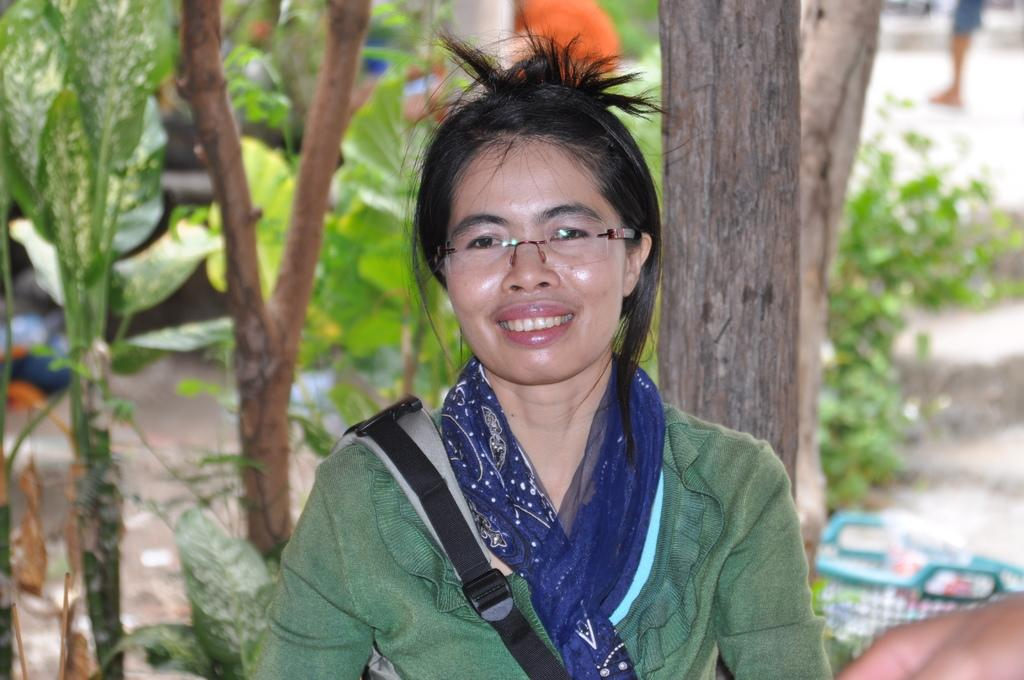What is the main subject of the image? There is a lady in the image. What accessories is the lady wearing? The lady is wearing specs and a scarf. What is the lady carrying in the image? The lady is carrying a bag. What can be seen in the background of the image? There are trees, plants, and a basket in the background of the image. How would you describe the background of the image? The background appears blurred. How many people are in the crowd in the image? There is no crowd present in the image; it features a lady with a blurred background. What type of dock can be seen in the image? There is no dock present in the image. 